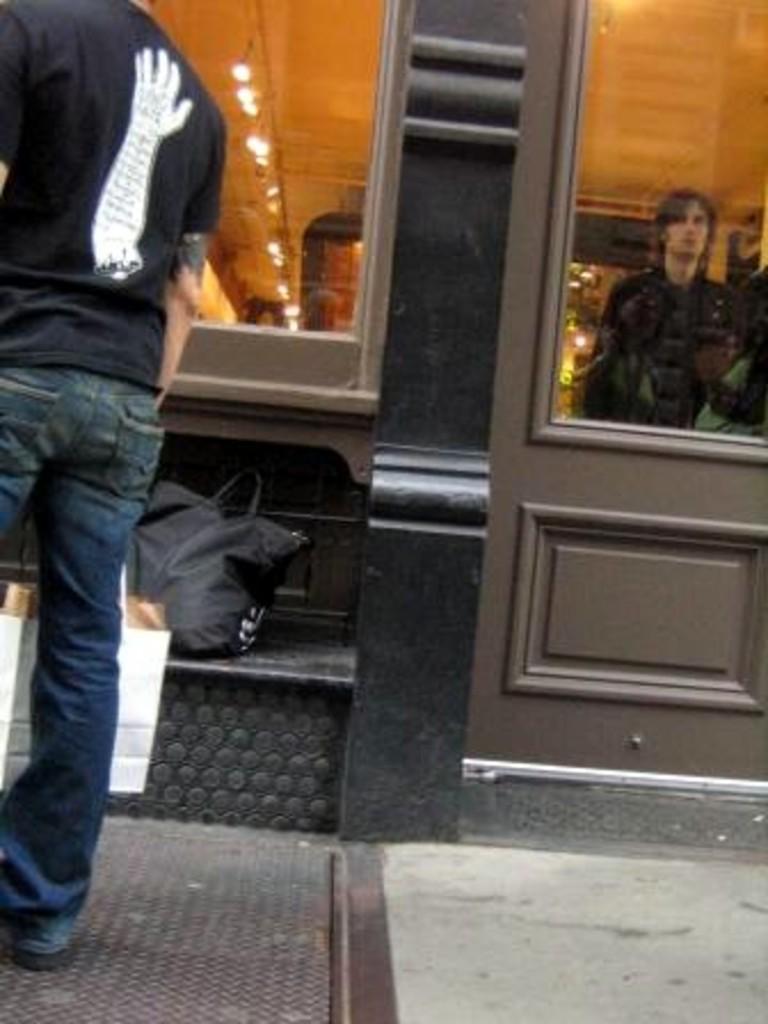Please provide a concise description of this image. Through glass we can see a person and lights. On the left side of the picture we can see a man wearing a black t-shirt and jeans standing. We can see bags in white and black color. 